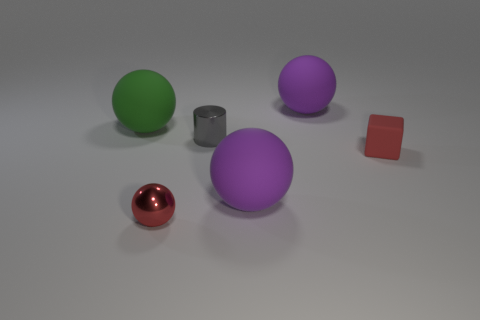There is a big purple thing that is in front of the small gray cylinder; is it the same shape as the gray thing?
Give a very brief answer. No. How many objects are small rubber objects or purple objects to the right of the metal ball?
Your answer should be very brief. 3. Are there more tiny red matte cubes that are to the left of the cylinder than cyan objects?
Give a very brief answer. No. Are there the same number of rubber balls that are in front of the tiny red metal object and tiny red balls that are behind the matte block?
Your response must be concise. Yes. There is a tiny shiny thing that is right of the tiny red metallic sphere; is there a ball that is on the left side of it?
Make the answer very short. Yes. The big green object is what shape?
Provide a short and direct response. Sphere. What size is the metallic sphere that is the same color as the small matte thing?
Keep it short and to the point. Small. There is a metallic cylinder that is right of the large thing that is on the left side of the small cylinder; what is its size?
Provide a succinct answer. Small. How big is the gray metal cylinder right of the red shiny object?
Keep it short and to the point. Small. Is the number of tiny blocks in front of the tiny ball less than the number of small cubes left of the metal cylinder?
Your answer should be compact. No. 